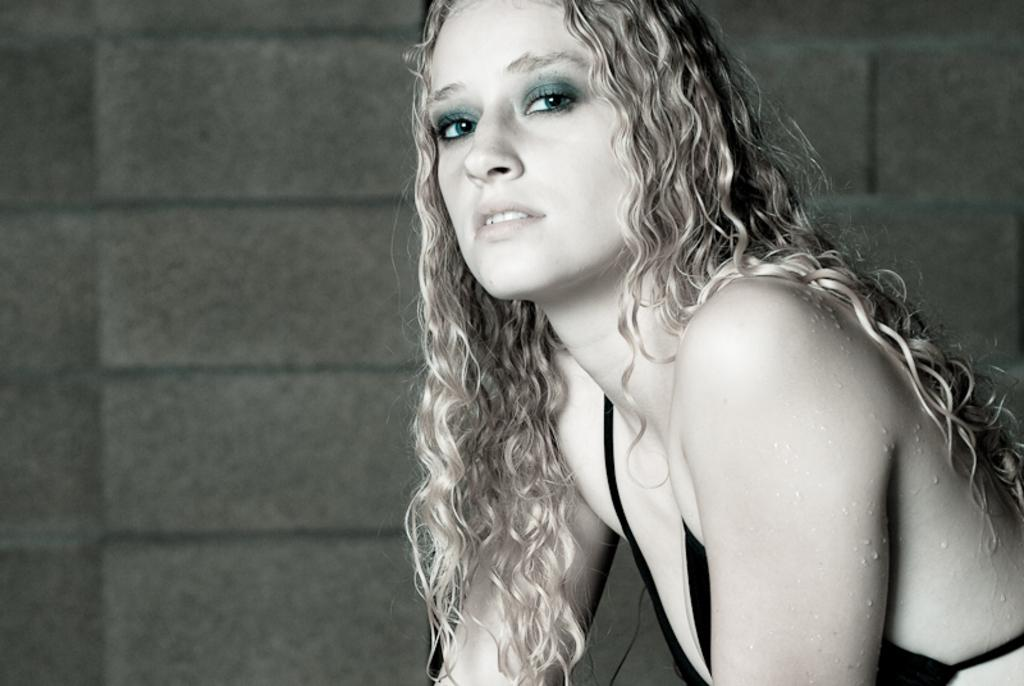Who is present in the image? There is a woman in the image. Where is the woman located in the image? The woman is sitting at the right side. What is the color of the woman's hair? The woman has blonde hair. What is the woman wearing in the image? The woman is wearing a black dress. What can be seen behind the woman in the image? There is a wall at the back of the image. Can you hear the sound of the sea in the image? There is no reference to the sea or any sounds in the image, so it's not possible to determine if the sound of the sea can be heard. 